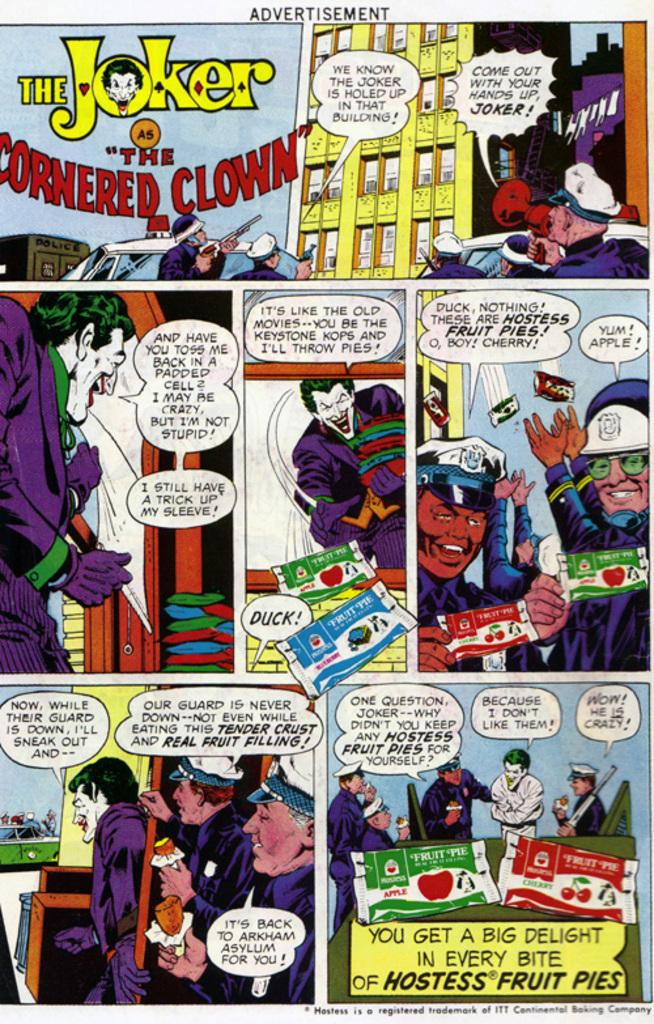<image>
Give a short and clear explanation of the subsequent image. A comic strip has The Joker in yellow. 